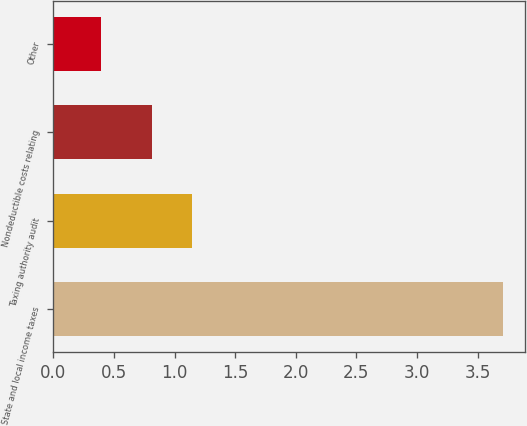Convert chart to OTSL. <chart><loc_0><loc_0><loc_500><loc_500><bar_chart><fcel>State and local income taxes<fcel>Taxing authority audit<fcel>Nondeductible costs relating<fcel>Other<nl><fcel>3.71<fcel>1.14<fcel>0.81<fcel>0.39<nl></chart> 